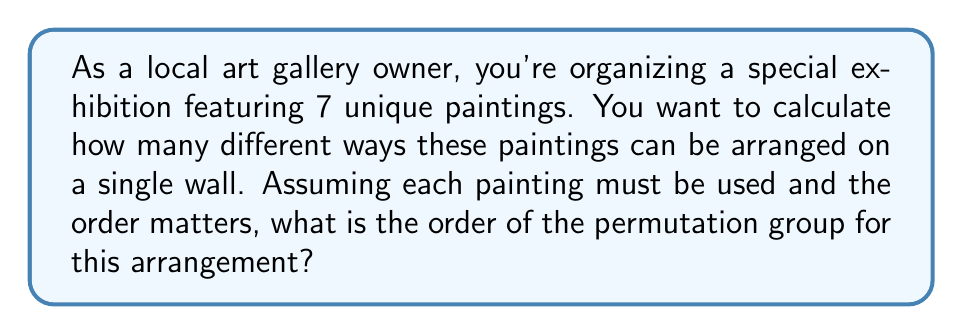Give your solution to this math problem. To solve this problem, we need to understand the concept of permutations in group theory.

1. In this scenario, we are dealing with a permutation of 7 distinct objects (the paintings).

2. The order of the permutation group for n distinct objects is given by n!, where n! represents the factorial of n.

3. The factorial of a positive integer n, denoted as n!, is the product of all positive integers less than or equal to n.

4. In this case, we have 7 paintings, so we need to calculate 7!.

5. Let's expand this calculation:

   $$7! = 7 \times 6 \times 5 \times 4 \times 3 \times 2 \times 1$$

6. Evaluating this expression:

   $$7! = 5040$$

7. Therefore, the order of the permutation group for arranging 7 paintings is 5040.

This means there are 5040 different ways to arrange the 7 paintings on the wall, each representing a unique permutation in the group.
Answer: The order of the permutation group for arranging 7 paintings is 5040. 